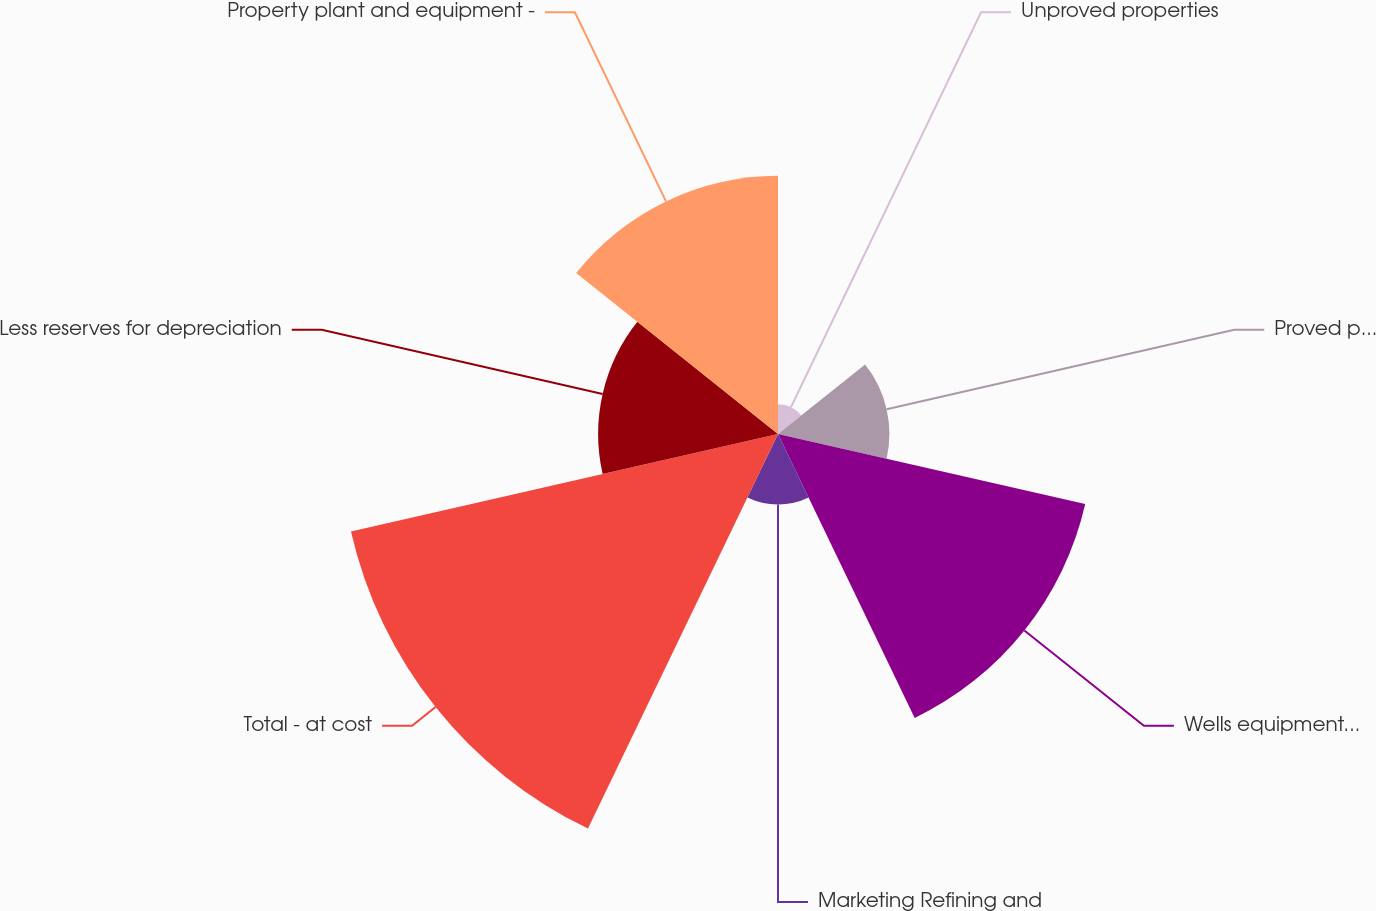Convert chart. <chart><loc_0><loc_0><loc_500><loc_500><pie_chart><fcel>Unproved properties<fcel>Proved properties<fcel>Wells equipment and related<fcel>Marketing Refining and<fcel>Total - at cost<fcel>Less reserves for depreciation<fcel>Property plant and equipment -<nl><fcel>2.12%<fcel>7.94%<fcel>22.46%<fcel>5.03%<fcel>31.22%<fcel>12.82%<fcel>18.4%<nl></chart> 